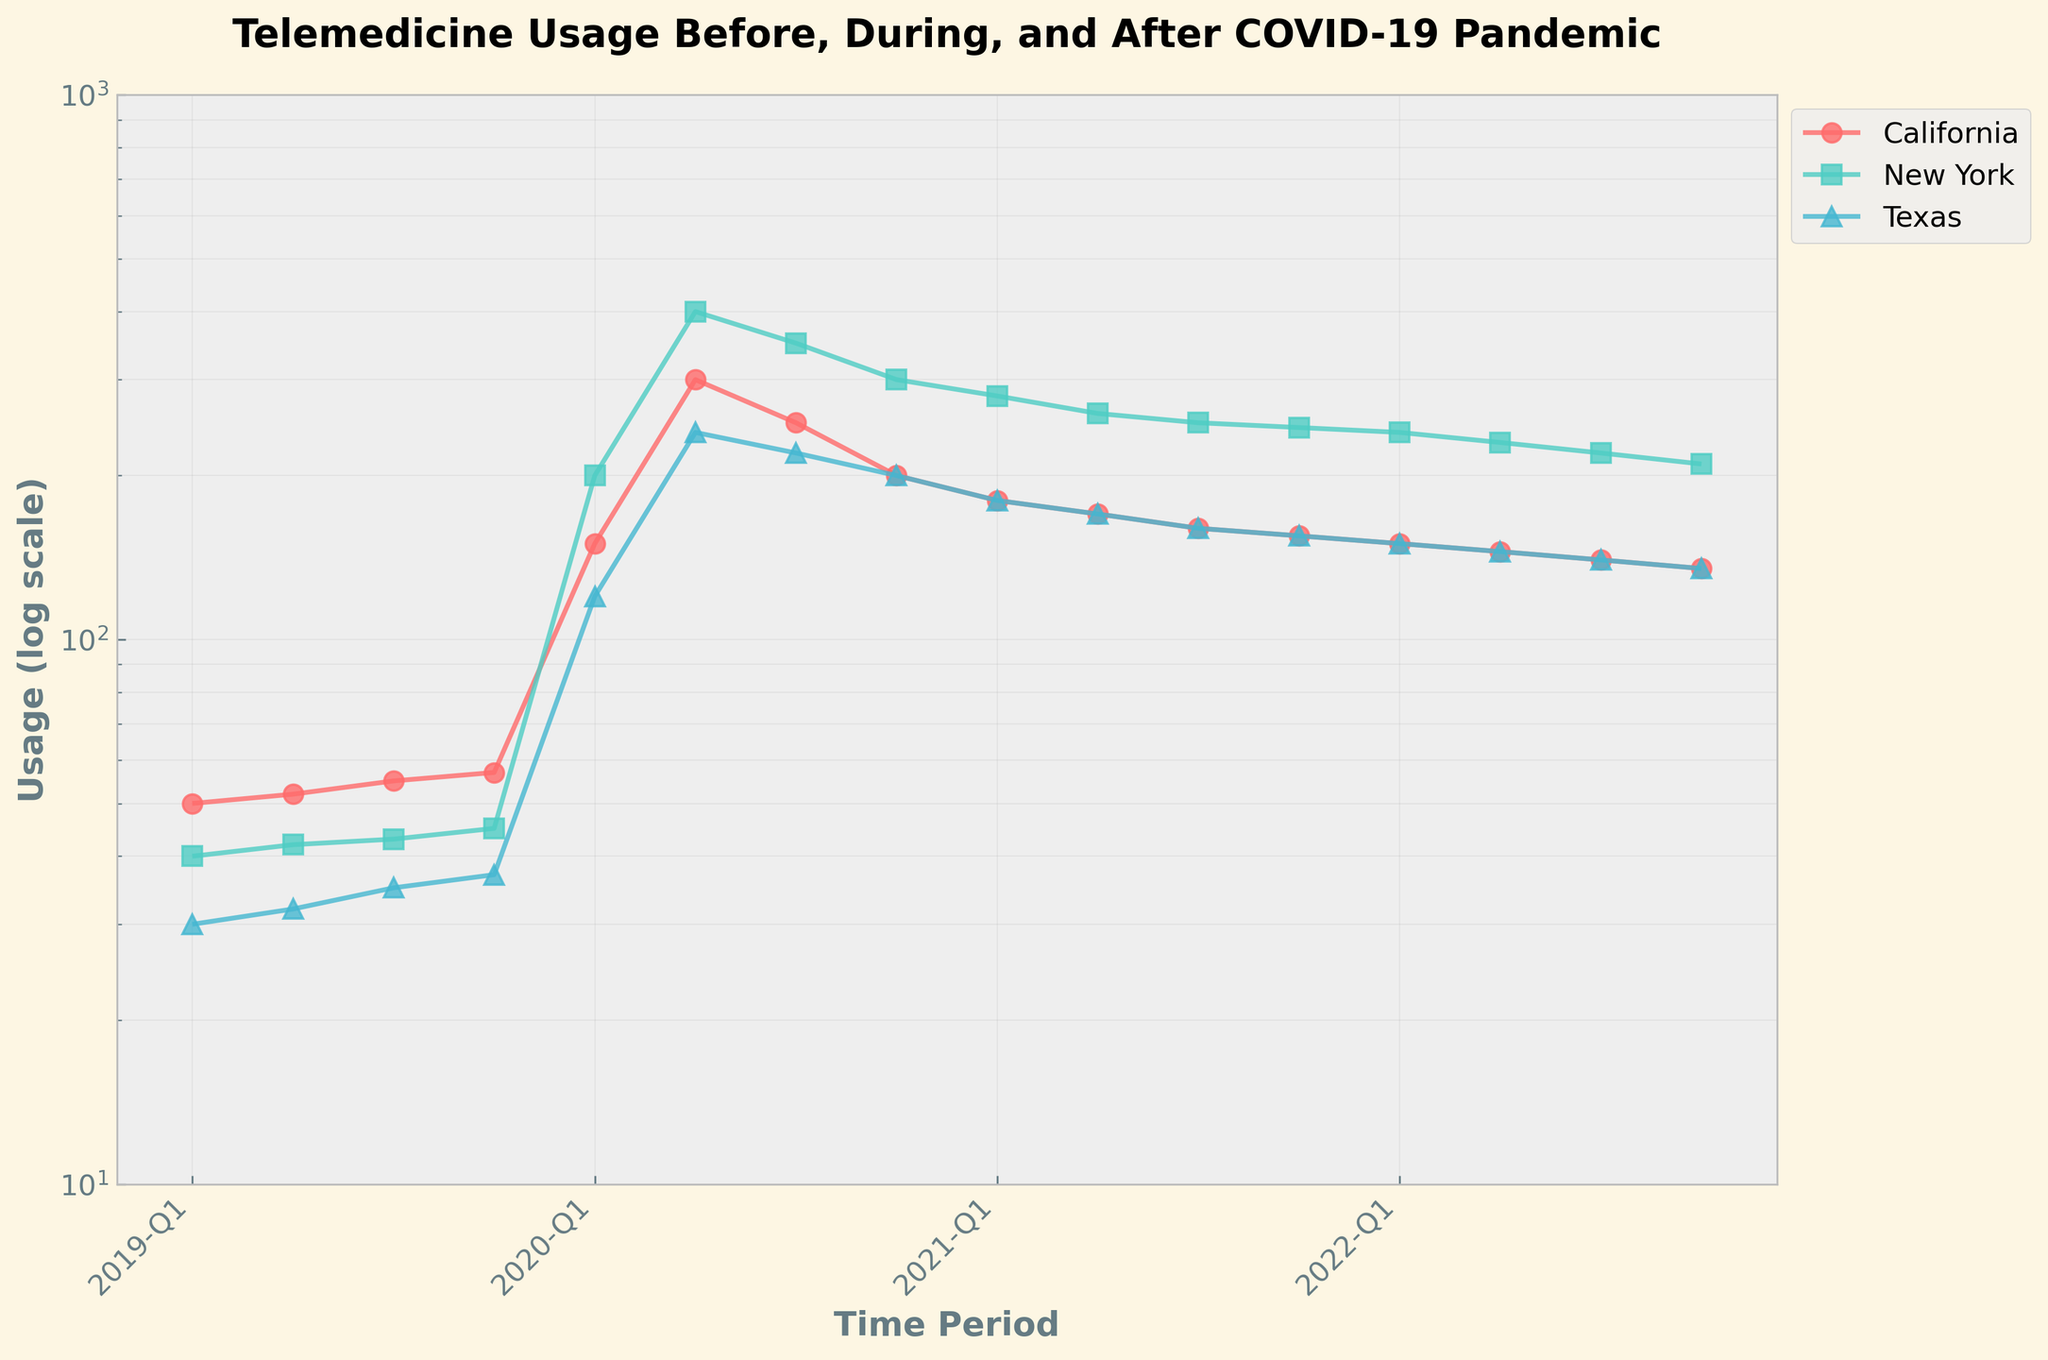How did the telemedicine usage change in California between 2019-Q1 and 2020-Q1? The usage in California in 2019-Q1 was 50, and in 2020-Q1 it was 150. The change is 150 - 50, which is an increase of 100.
Answer: Increased by 100 Which state had the highest peak usage during the observed period, and what was the value? In the plot, New York had the highest peak usage, reaching 400 during 2020-Q2.
Answer: New York, 400 Compare the usage trends in Texas and California after 2020-Q2 until the end of the period. Which state saw a bigger decline in telemedicine usage? After 2020-Q2, California's usage declined from 300 to 135 by 2022-Q4, a drop of 165. Texas's usage declined from 240 to 135, a drop of 105. California saw the bigger decline.
Answer: California At what point did California and Texas both drop to around 150 in telemedicine usage? According to the plot, California and Texas both dropped to around 150 in 2022-Q1.
Answer: 2022-Q1 What is the percentage change in New York's telemedicine usage from 2020-Q2 to 2022-Q4? New York's usage in 2020-Q2 was 400, and in 2022-Q4 it was 210. The percentage change is ((210 - 400) / 400) * 100 = -47.5%.
Answer: -47.5% How do the slopes of the lines represent the changes in telemedicine usage for the three states during 2020-Q1 to 2020-Q2? On a log scale, the steeper the slope, the more significant the percentage change. New York has the steepest slope indicating the largest relative increase, followed by California, then Texas.
Answer: New York > California > Texas Identify the quarter where the usage started to consistently decline for all three states. The quarter when all three states started to consistently decline in usage was 2020-Q3.
Answer: 2020-Q3 